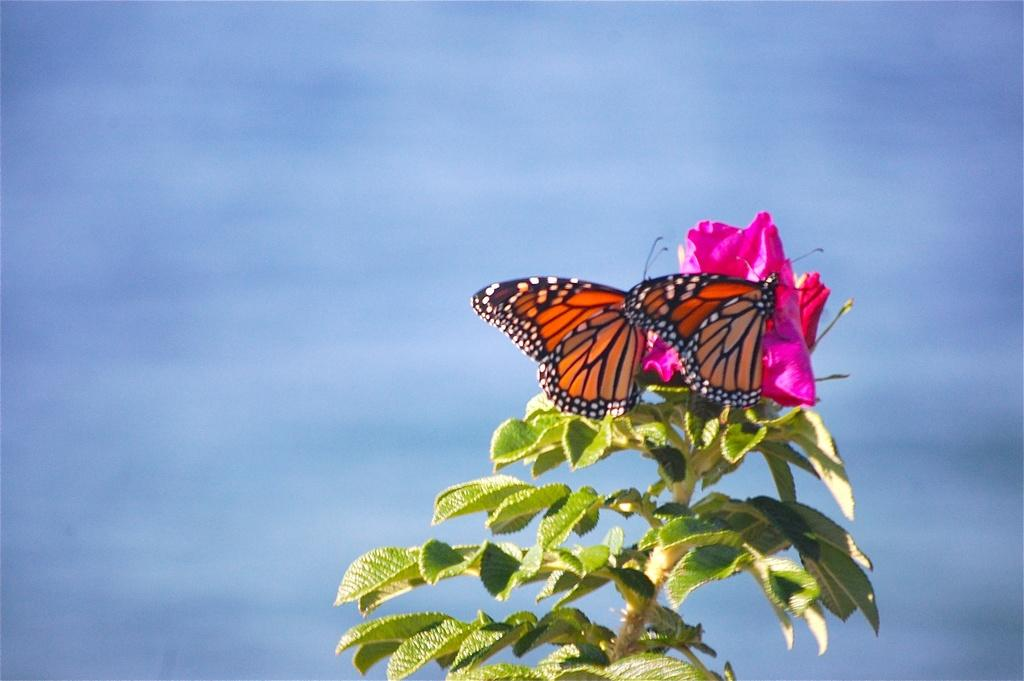What is in the foreground of the picture? There is a plant in the foreground of the picture. What can be observed about the plant's stem? The stem has leaves. What else is present on the plant? The plant has flowers. What is interacting with the flowers? There are butterflies on the flowers. How would you describe the background of the image? The background of the image is blurred. Can you tell me how many times the street is mentioned in the image? There is no mention of a street in the image; it features a plant with flowers and butterflies. What thought process is the plant going through while the butterflies are on its flowers? Plants do not have thoughts or thought processes, so this question cannot be answered. 